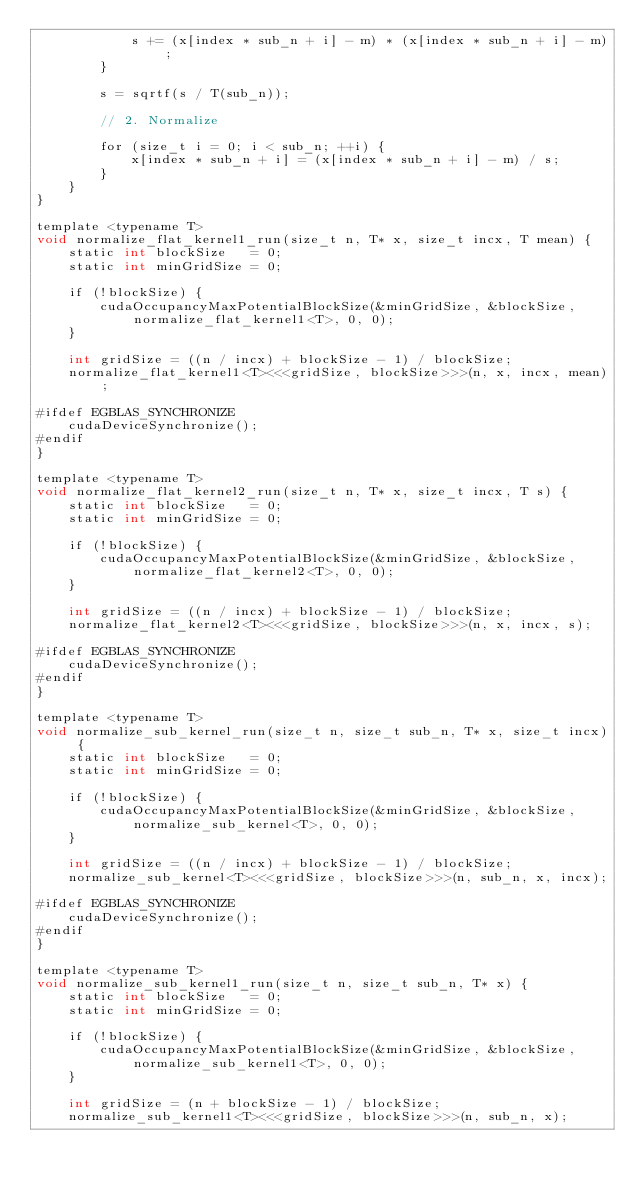Convert code to text. <code><loc_0><loc_0><loc_500><loc_500><_Cuda_>            s += (x[index * sub_n + i] - m) * (x[index * sub_n + i] - m);
        }

        s = sqrtf(s / T(sub_n));

        // 2. Normalize

        for (size_t i = 0; i < sub_n; ++i) {
            x[index * sub_n + i] = (x[index * sub_n + i] - m) / s;
        }
    }
}

template <typename T>
void normalize_flat_kernel1_run(size_t n, T* x, size_t incx, T mean) {
    static int blockSize   = 0;
    static int minGridSize = 0;

    if (!blockSize) {
        cudaOccupancyMaxPotentialBlockSize(&minGridSize, &blockSize, normalize_flat_kernel1<T>, 0, 0);
    }

    int gridSize = ((n / incx) + blockSize - 1) / blockSize;
    normalize_flat_kernel1<T><<<gridSize, blockSize>>>(n, x, incx, mean);

#ifdef EGBLAS_SYNCHRONIZE
    cudaDeviceSynchronize();
#endif
}

template <typename T>
void normalize_flat_kernel2_run(size_t n, T* x, size_t incx, T s) {
    static int blockSize   = 0;
    static int minGridSize = 0;

    if (!blockSize) {
        cudaOccupancyMaxPotentialBlockSize(&minGridSize, &blockSize, normalize_flat_kernel2<T>, 0, 0);
    }

    int gridSize = ((n / incx) + blockSize - 1) / blockSize;
    normalize_flat_kernel2<T><<<gridSize, blockSize>>>(n, x, incx, s);

#ifdef EGBLAS_SYNCHRONIZE
    cudaDeviceSynchronize();
#endif
}

template <typename T>
void normalize_sub_kernel_run(size_t n, size_t sub_n, T* x, size_t incx) {
    static int blockSize   = 0;
    static int minGridSize = 0;

    if (!blockSize) {
        cudaOccupancyMaxPotentialBlockSize(&minGridSize, &blockSize, normalize_sub_kernel<T>, 0, 0);
    }

    int gridSize = ((n / incx) + blockSize - 1) / blockSize;
    normalize_sub_kernel<T><<<gridSize, blockSize>>>(n, sub_n, x, incx);

#ifdef EGBLAS_SYNCHRONIZE
    cudaDeviceSynchronize();
#endif
}

template <typename T>
void normalize_sub_kernel1_run(size_t n, size_t sub_n, T* x) {
    static int blockSize   = 0;
    static int minGridSize = 0;

    if (!blockSize) {
        cudaOccupancyMaxPotentialBlockSize(&minGridSize, &blockSize, normalize_sub_kernel1<T>, 0, 0);
    }

    int gridSize = (n + blockSize - 1) / blockSize;
    normalize_sub_kernel1<T><<<gridSize, blockSize>>>(n, sub_n, x);
</code> 